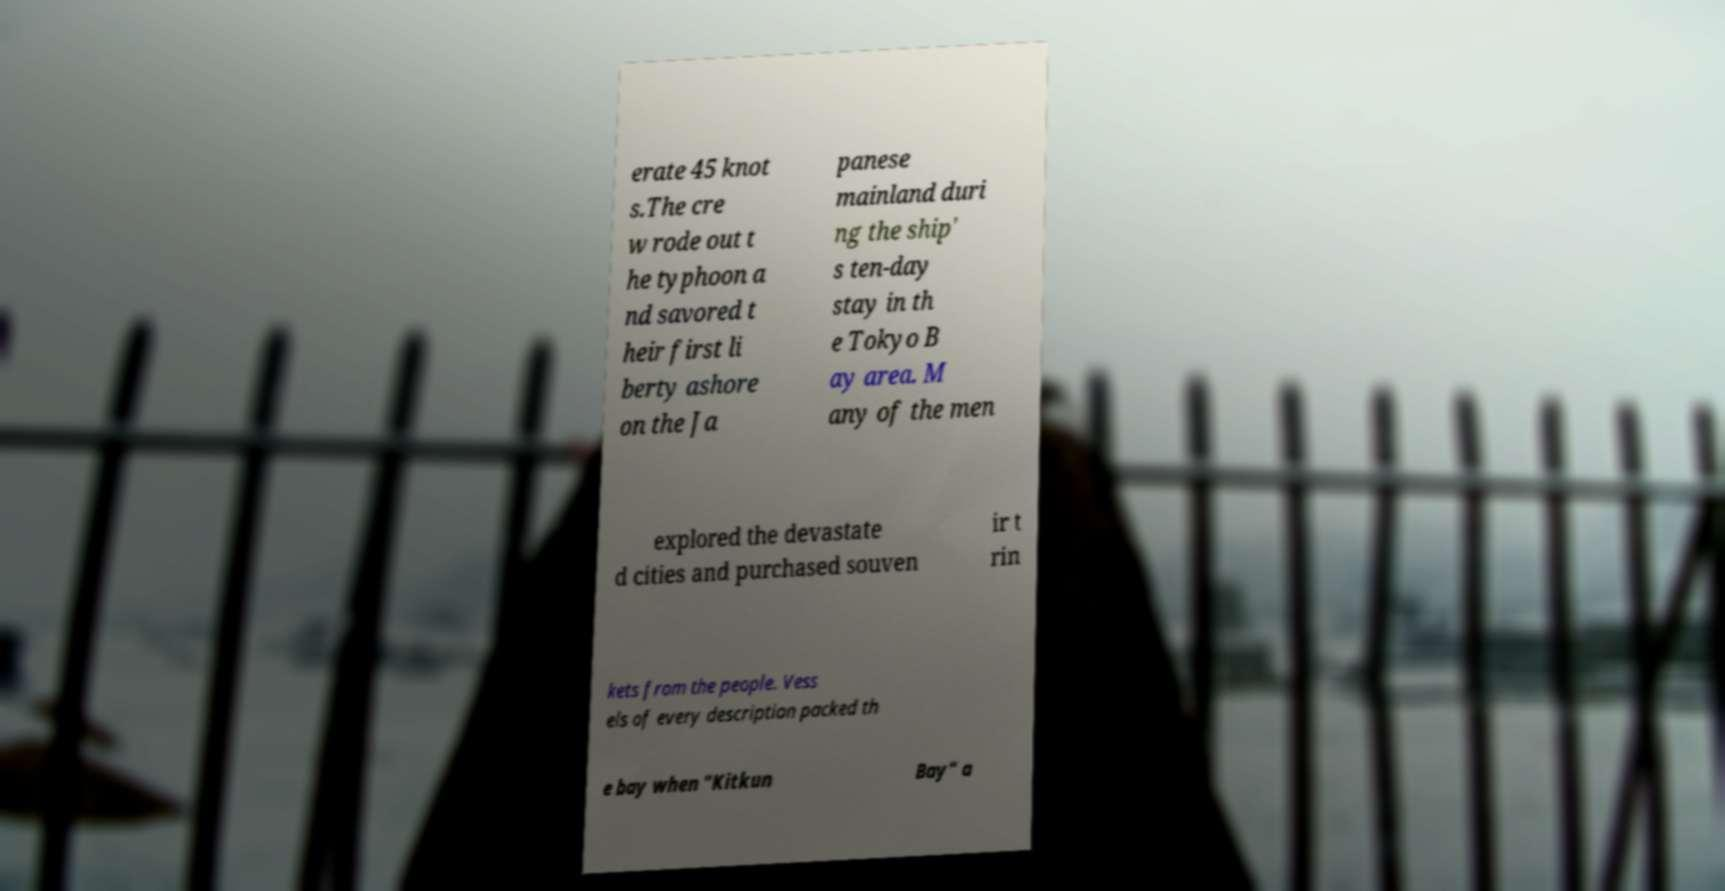Please read and relay the text visible in this image. What does it say? erate 45 knot s.The cre w rode out t he typhoon a nd savored t heir first li berty ashore on the Ja panese mainland duri ng the ship' s ten-day stay in th e Tokyo B ay area. M any of the men explored the devastate d cities and purchased souven ir t rin kets from the people. Vess els of every description packed th e bay when "Kitkun Bay" a 